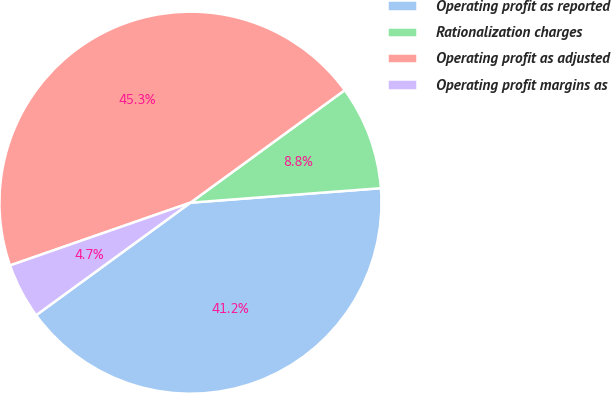Convert chart to OTSL. <chart><loc_0><loc_0><loc_500><loc_500><pie_chart><fcel>Operating profit as reported<fcel>Rationalization charges<fcel>Operating profit as adjusted<fcel>Operating profit margins as<nl><fcel>41.18%<fcel>8.82%<fcel>45.3%<fcel>4.7%<nl></chart> 